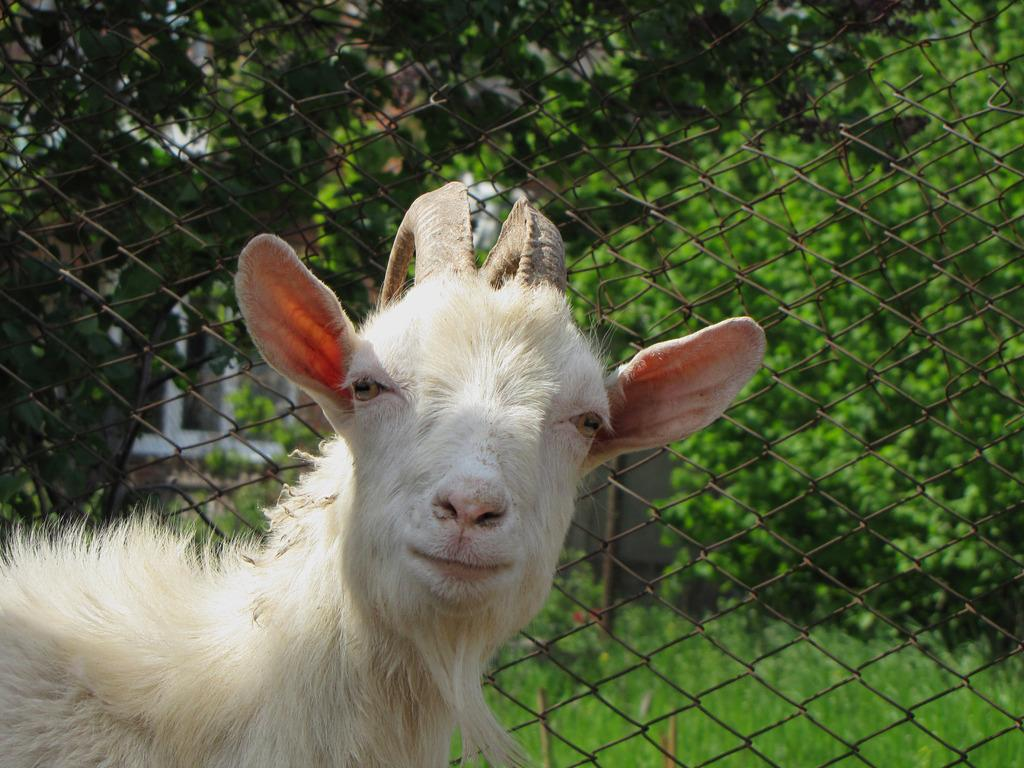What type of living creature can be seen in the image? There is an animal in the image. What is the material of the fencing in the image? There is metal fencing in the image. What type of vegetation is present in the image? Grass is present in the image. What other natural elements can be seen in the image? There are trees in the image. What time of day is the train passing by in the image? There is no train present in the image, so it is not possible to determine the time of day based on a train's presence. 